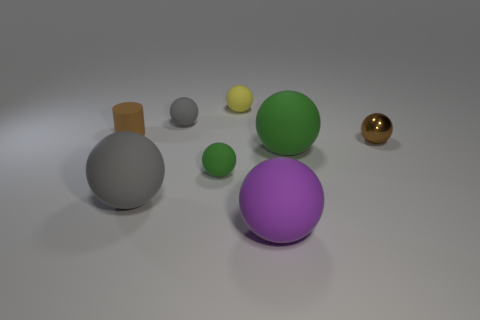How many gray balls must be subtracted to get 1 gray balls? 1 Subtract all purple balls. How many balls are left? 6 Subtract all purple cubes. How many green balls are left? 2 Subtract all brown spheres. How many spheres are left? 6 Add 2 gray objects. How many objects exist? 10 Subtract all cylinders. How many objects are left? 7 Subtract all brown spheres. Subtract all purple cylinders. How many spheres are left? 6 Add 1 tiny brown metallic balls. How many tiny brown metallic balls are left? 2 Add 8 yellow rubber things. How many yellow rubber things exist? 9 Subtract 0 blue spheres. How many objects are left? 8 